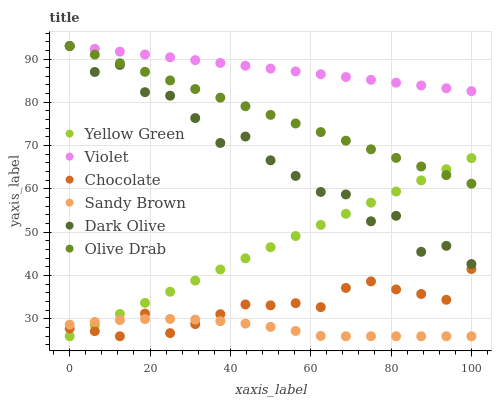Does Sandy Brown have the minimum area under the curve?
Answer yes or no. Yes. Does Violet have the maximum area under the curve?
Answer yes or no. Yes. Does Dark Olive have the minimum area under the curve?
Answer yes or no. No. Does Dark Olive have the maximum area under the curve?
Answer yes or no. No. Is Yellow Green the smoothest?
Answer yes or no. Yes. Is Dark Olive the roughest?
Answer yes or no. Yes. Is Chocolate the smoothest?
Answer yes or no. No. Is Chocolate the roughest?
Answer yes or no. No. Does Yellow Green have the lowest value?
Answer yes or no. Yes. Does Dark Olive have the lowest value?
Answer yes or no. No. Does Olive Drab have the highest value?
Answer yes or no. Yes. Does Chocolate have the highest value?
Answer yes or no. No. Is Chocolate less than Dark Olive?
Answer yes or no. Yes. Is Dark Olive greater than Sandy Brown?
Answer yes or no. Yes. Does Olive Drab intersect Yellow Green?
Answer yes or no. Yes. Is Olive Drab less than Yellow Green?
Answer yes or no. No. Is Olive Drab greater than Yellow Green?
Answer yes or no. No. Does Chocolate intersect Dark Olive?
Answer yes or no. No. 